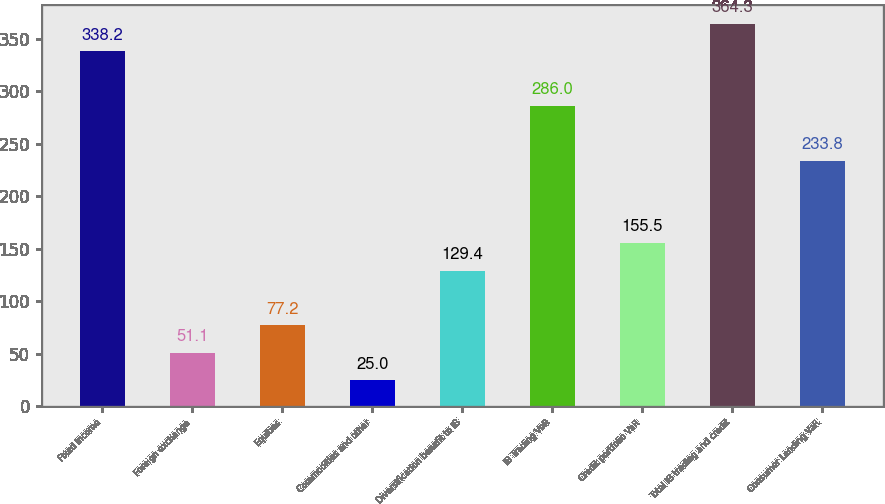<chart> <loc_0><loc_0><loc_500><loc_500><bar_chart><fcel>Fixed income<fcel>Foreign exchange<fcel>Equities<fcel>Commodities and other<fcel>Diversification benefit to IB<fcel>IB Trading VaR<fcel>Credit portfolio VaR<fcel>Total IB trading and credit<fcel>Consumer Lending VaR<nl><fcel>338.2<fcel>51.1<fcel>77.2<fcel>25<fcel>129.4<fcel>286<fcel>155.5<fcel>364.3<fcel>233.8<nl></chart> 